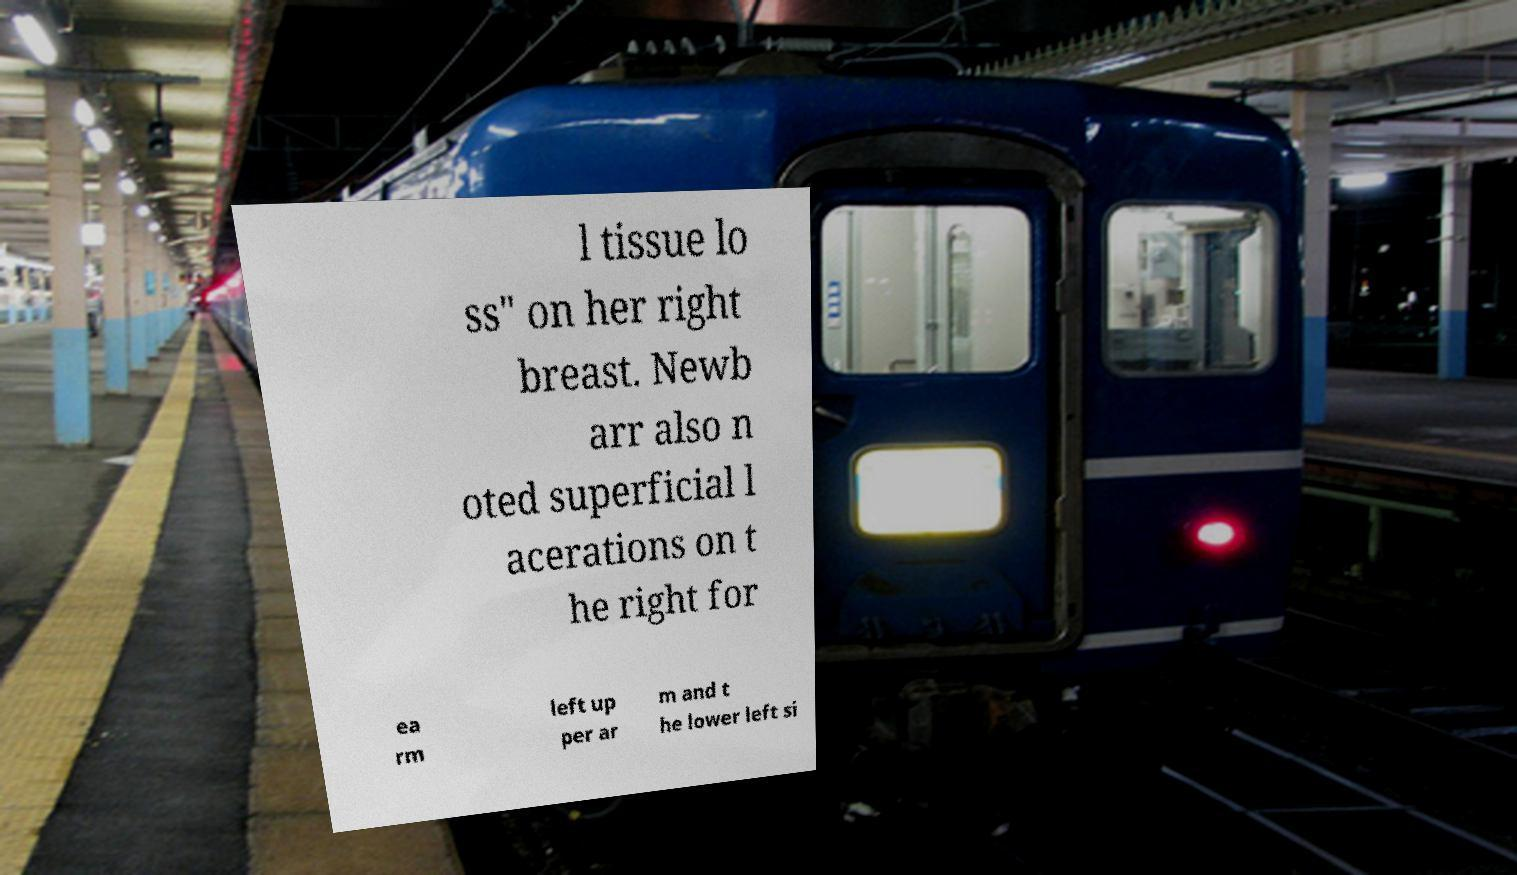For documentation purposes, I need the text within this image transcribed. Could you provide that? l tissue lo ss" on her right breast. Newb arr also n oted superficial l acerations on t he right for ea rm left up per ar m and t he lower left si 